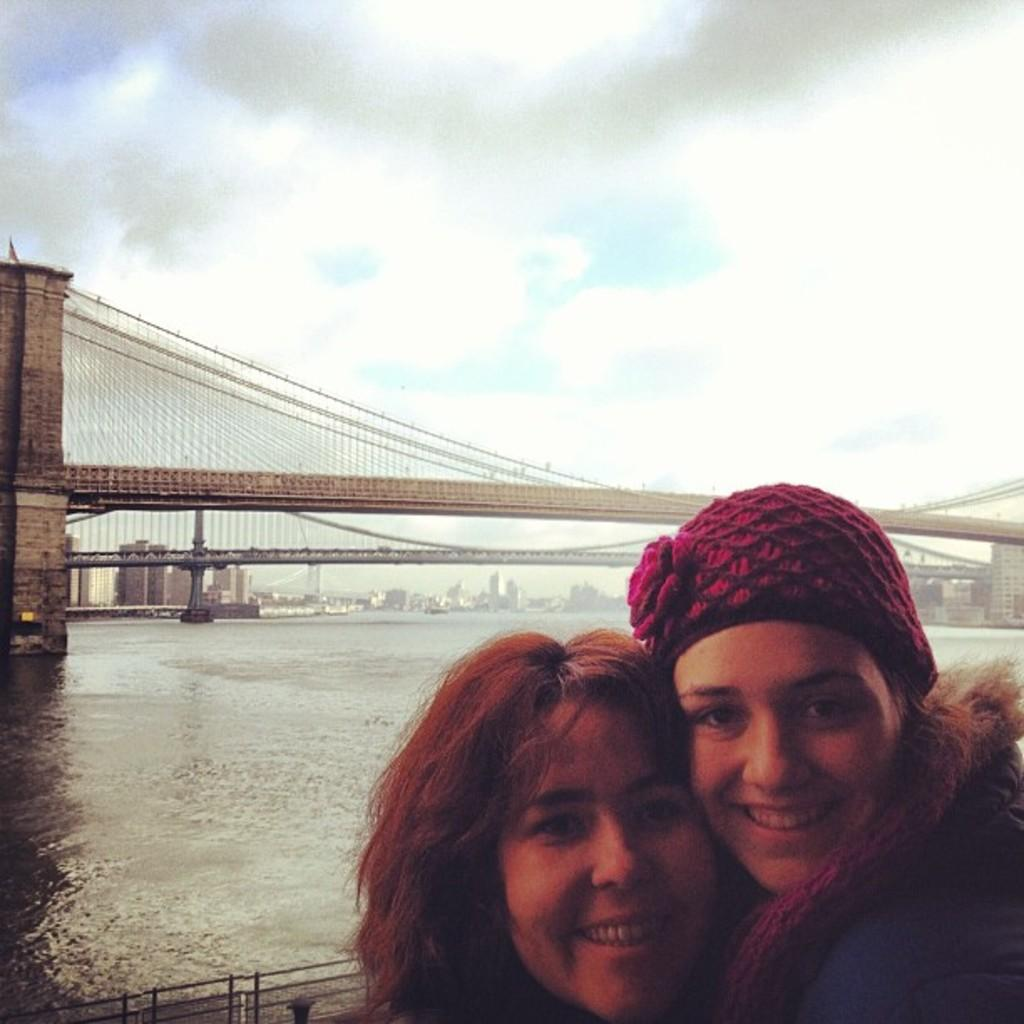Who can be seen in the foreground of the image? There are two ladies in the foreground of the image. What is visible in the background of the image? There is a bridge and buildings in the background of the image. What natural element can be seen in the image? There is water visible in the image. What is visible at the top of the image? The sky is visible at the top of the image. Can you describe the wave pattern of the ladies' clothing in the image? There is no wave pattern mentioned or visible on the ladies' clothing in the image. 